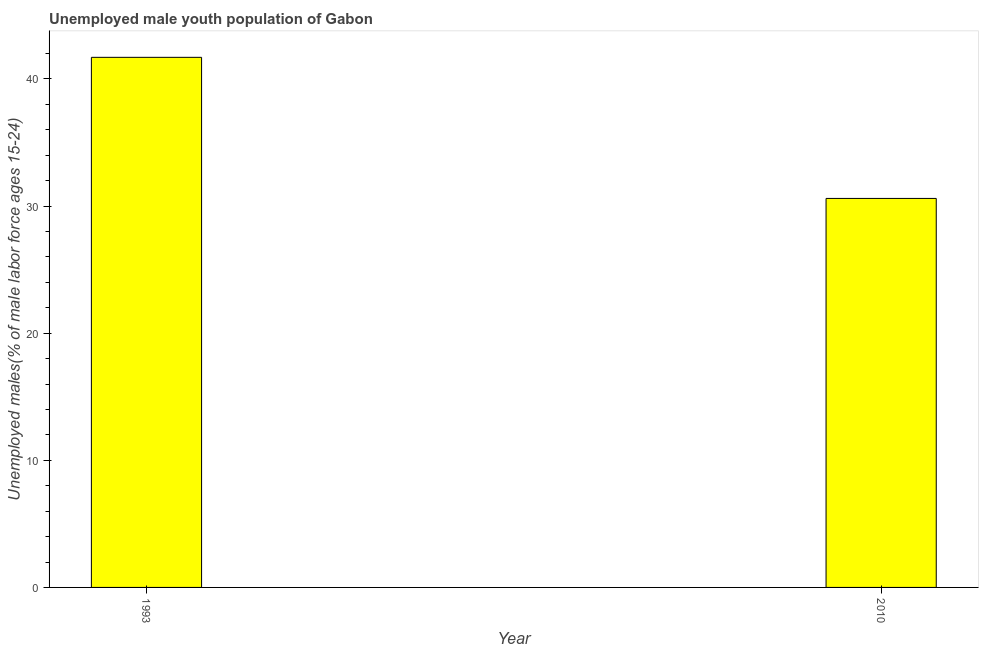Does the graph contain any zero values?
Give a very brief answer. No. What is the title of the graph?
Your answer should be compact. Unemployed male youth population of Gabon. What is the label or title of the Y-axis?
Provide a succinct answer. Unemployed males(% of male labor force ages 15-24). What is the unemployed male youth in 1993?
Your response must be concise. 41.7. Across all years, what is the maximum unemployed male youth?
Your answer should be compact. 41.7. Across all years, what is the minimum unemployed male youth?
Make the answer very short. 30.6. What is the sum of the unemployed male youth?
Make the answer very short. 72.3. What is the difference between the unemployed male youth in 1993 and 2010?
Make the answer very short. 11.1. What is the average unemployed male youth per year?
Keep it short and to the point. 36.15. What is the median unemployed male youth?
Your answer should be compact. 36.15. Do a majority of the years between 1993 and 2010 (inclusive) have unemployed male youth greater than 40 %?
Make the answer very short. No. What is the ratio of the unemployed male youth in 1993 to that in 2010?
Offer a terse response. 1.36. In how many years, is the unemployed male youth greater than the average unemployed male youth taken over all years?
Keep it short and to the point. 1. How many bars are there?
Your answer should be very brief. 2. Are all the bars in the graph horizontal?
Your response must be concise. No. What is the difference between two consecutive major ticks on the Y-axis?
Ensure brevity in your answer.  10. Are the values on the major ticks of Y-axis written in scientific E-notation?
Your response must be concise. No. What is the Unemployed males(% of male labor force ages 15-24) in 1993?
Keep it short and to the point. 41.7. What is the Unemployed males(% of male labor force ages 15-24) in 2010?
Offer a very short reply. 30.6. What is the ratio of the Unemployed males(% of male labor force ages 15-24) in 1993 to that in 2010?
Your answer should be very brief. 1.36. 